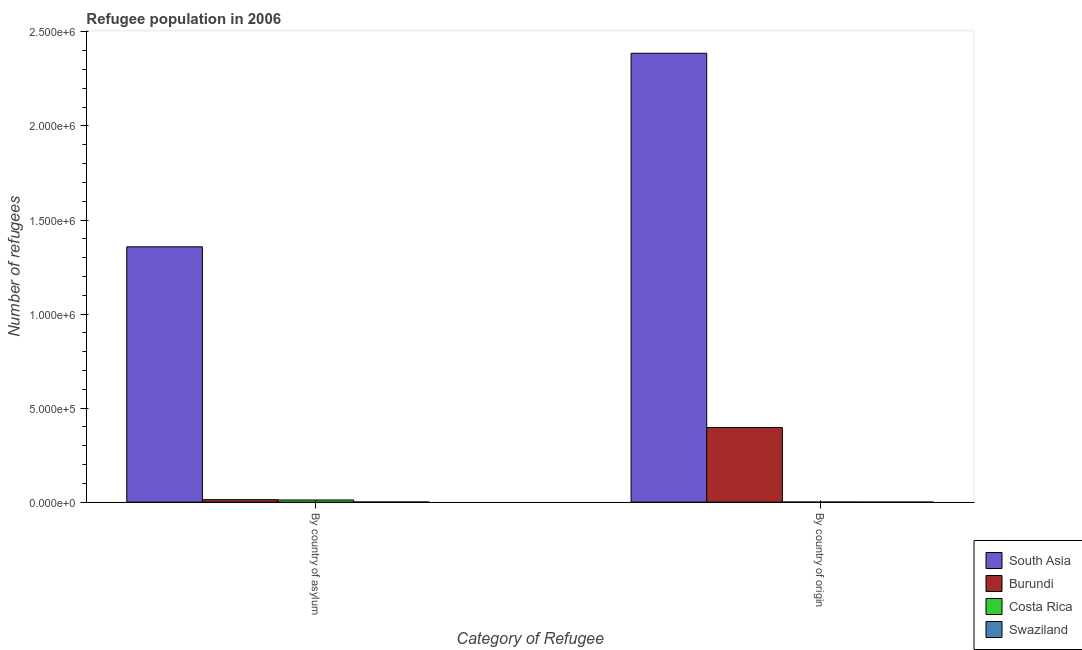Are the number of bars per tick equal to the number of legend labels?
Provide a succinct answer. Yes. How many bars are there on the 2nd tick from the right?
Make the answer very short. 4. What is the label of the 1st group of bars from the left?
Ensure brevity in your answer.  By country of asylum. What is the number of refugees by country of origin in South Asia?
Offer a terse response. 2.39e+06. Across all countries, what is the maximum number of refugees by country of asylum?
Ensure brevity in your answer.  1.36e+06. Across all countries, what is the minimum number of refugees by country of origin?
Provide a short and direct response. 22. In which country was the number of refugees by country of origin maximum?
Offer a very short reply. South Asia. In which country was the number of refugees by country of asylum minimum?
Give a very brief answer. Swaziland. What is the total number of refugees by country of origin in the graph?
Give a very brief answer. 2.78e+06. What is the difference between the number of refugees by country of asylum in Burundi and that in Costa Rica?
Offer a terse response. 1661. What is the difference between the number of refugees by country of origin in Costa Rica and the number of refugees by country of asylum in South Asia?
Your response must be concise. -1.36e+06. What is the average number of refugees by country of origin per country?
Give a very brief answer. 6.96e+05. What is the difference between the number of refugees by country of origin and number of refugees by country of asylum in Costa Rica?
Provide a short and direct response. -1.12e+04. What is the ratio of the number of refugees by country of asylum in Costa Rica to that in Burundi?
Give a very brief answer. 0.87. Is the number of refugees by country of asylum in Swaziland less than that in South Asia?
Your answer should be compact. Yes. In how many countries, is the number of refugees by country of asylum greater than the average number of refugees by country of asylum taken over all countries?
Offer a terse response. 1. What does the 4th bar from the left in By country of asylum represents?
Your response must be concise. Swaziland. How many bars are there?
Give a very brief answer. 8. How many countries are there in the graph?
Provide a short and direct response. 4. Does the graph contain grids?
Your answer should be very brief. No. Where does the legend appear in the graph?
Your answer should be very brief. Bottom right. How many legend labels are there?
Ensure brevity in your answer.  4. How are the legend labels stacked?
Your answer should be compact. Vertical. What is the title of the graph?
Your answer should be very brief. Refugee population in 2006. What is the label or title of the X-axis?
Give a very brief answer. Category of Refugee. What is the label or title of the Y-axis?
Make the answer very short. Number of refugees. What is the Number of refugees of South Asia in By country of asylum?
Give a very brief answer. 1.36e+06. What is the Number of refugees of Burundi in By country of asylum?
Give a very brief answer. 1.32e+04. What is the Number of refugees of Costa Rica in By country of asylum?
Your response must be concise. 1.15e+04. What is the Number of refugees of Swaziland in By country of asylum?
Provide a succinct answer. 752. What is the Number of refugees in South Asia in By country of origin?
Your response must be concise. 2.39e+06. What is the Number of refugees of Burundi in By country of origin?
Your answer should be compact. 3.97e+05. What is the Number of refugees of Costa Rica in By country of origin?
Give a very brief answer. 284. Across all Category of Refugee, what is the maximum Number of refugees of South Asia?
Provide a short and direct response. 2.39e+06. Across all Category of Refugee, what is the maximum Number of refugees of Burundi?
Provide a succinct answer. 3.97e+05. Across all Category of Refugee, what is the maximum Number of refugees of Costa Rica?
Give a very brief answer. 1.15e+04. Across all Category of Refugee, what is the maximum Number of refugees of Swaziland?
Your answer should be compact. 752. Across all Category of Refugee, what is the minimum Number of refugees of South Asia?
Offer a very short reply. 1.36e+06. Across all Category of Refugee, what is the minimum Number of refugees of Burundi?
Make the answer very short. 1.32e+04. Across all Category of Refugee, what is the minimum Number of refugees of Costa Rica?
Give a very brief answer. 284. Across all Category of Refugee, what is the minimum Number of refugees in Swaziland?
Offer a very short reply. 22. What is the total Number of refugees of South Asia in the graph?
Offer a terse response. 3.74e+06. What is the total Number of refugees in Burundi in the graph?
Your response must be concise. 4.10e+05. What is the total Number of refugees of Costa Rica in the graph?
Provide a succinct answer. 1.18e+04. What is the total Number of refugees of Swaziland in the graph?
Provide a short and direct response. 774. What is the difference between the Number of refugees of South Asia in By country of asylum and that in By country of origin?
Provide a short and direct response. -1.03e+06. What is the difference between the Number of refugees of Burundi in By country of asylum and that in By country of origin?
Offer a terse response. -3.83e+05. What is the difference between the Number of refugees in Costa Rica in By country of asylum and that in By country of origin?
Ensure brevity in your answer.  1.12e+04. What is the difference between the Number of refugees in Swaziland in By country of asylum and that in By country of origin?
Your answer should be compact. 730. What is the difference between the Number of refugees in South Asia in By country of asylum and the Number of refugees in Burundi in By country of origin?
Provide a short and direct response. 9.61e+05. What is the difference between the Number of refugees of South Asia in By country of asylum and the Number of refugees of Costa Rica in By country of origin?
Your answer should be very brief. 1.36e+06. What is the difference between the Number of refugees of South Asia in By country of asylum and the Number of refugees of Swaziland in By country of origin?
Provide a short and direct response. 1.36e+06. What is the difference between the Number of refugees in Burundi in By country of asylum and the Number of refugees in Costa Rica in By country of origin?
Offer a terse response. 1.29e+04. What is the difference between the Number of refugees of Burundi in By country of asylum and the Number of refugees of Swaziland in By country of origin?
Your response must be concise. 1.32e+04. What is the difference between the Number of refugees in Costa Rica in By country of asylum and the Number of refugees in Swaziland in By country of origin?
Make the answer very short. 1.15e+04. What is the average Number of refugees in South Asia per Category of Refugee?
Your answer should be very brief. 1.87e+06. What is the average Number of refugees in Burundi per Category of Refugee?
Provide a short and direct response. 2.05e+05. What is the average Number of refugees of Costa Rica per Category of Refugee?
Provide a succinct answer. 5899.5. What is the average Number of refugees in Swaziland per Category of Refugee?
Your response must be concise. 387. What is the difference between the Number of refugees of South Asia and Number of refugees of Burundi in By country of asylum?
Give a very brief answer. 1.34e+06. What is the difference between the Number of refugees in South Asia and Number of refugees in Costa Rica in By country of asylum?
Provide a succinct answer. 1.35e+06. What is the difference between the Number of refugees in South Asia and Number of refugees in Swaziland in By country of asylum?
Your answer should be compact. 1.36e+06. What is the difference between the Number of refugees of Burundi and Number of refugees of Costa Rica in By country of asylum?
Your answer should be very brief. 1661. What is the difference between the Number of refugees of Burundi and Number of refugees of Swaziland in By country of asylum?
Offer a terse response. 1.24e+04. What is the difference between the Number of refugees of Costa Rica and Number of refugees of Swaziland in By country of asylum?
Offer a very short reply. 1.08e+04. What is the difference between the Number of refugees of South Asia and Number of refugees of Burundi in By country of origin?
Your answer should be compact. 1.99e+06. What is the difference between the Number of refugees of South Asia and Number of refugees of Costa Rica in By country of origin?
Your answer should be compact. 2.39e+06. What is the difference between the Number of refugees in South Asia and Number of refugees in Swaziland in By country of origin?
Make the answer very short. 2.39e+06. What is the difference between the Number of refugees in Burundi and Number of refugees in Costa Rica in By country of origin?
Your answer should be very brief. 3.96e+05. What is the difference between the Number of refugees of Burundi and Number of refugees of Swaziland in By country of origin?
Your answer should be compact. 3.97e+05. What is the difference between the Number of refugees of Costa Rica and Number of refugees of Swaziland in By country of origin?
Make the answer very short. 262. What is the ratio of the Number of refugees in South Asia in By country of asylum to that in By country of origin?
Offer a terse response. 0.57. What is the ratio of the Number of refugees in Burundi in By country of asylum to that in By country of origin?
Your answer should be very brief. 0.03. What is the ratio of the Number of refugees of Costa Rica in By country of asylum to that in By country of origin?
Offer a very short reply. 40.55. What is the ratio of the Number of refugees of Swaziland in By country of asylum to that in By country of origin?
Offer a terse response. 34.18. What is the difference between the highest and the second highest Number of refugees in South Asia?
Your answer should be very brief. 1.03e+06. What is the difference between the highest and the second highest Number of refugees in Burundi?
Give a very brief answer. 3.83e+05. What is the difference between the highest and the second highest Number of refugees of Costa Rica?
Your answer should be compact. 1.12e+04. What is the difference between the highest and the second highest Number of refugees of Swaziland?
Your response must be concise. 730. What is the difference between the highest and the lowest Number of refugees in South Asia?
Provide a succinct answer. 1.03e+06. What is the difference between the highest and the lowest Number of refugees of Burundi?
Provide a succinct answer. 3.83e+05. What is the difference between the highest and the lowest Number of refugees of Costa Rica?
Offer a terse response. 1.12e+04. What is the difference between the highest and the lowest Number of refugees of Swaziland?
Ensure brevity in your answer.  730. 